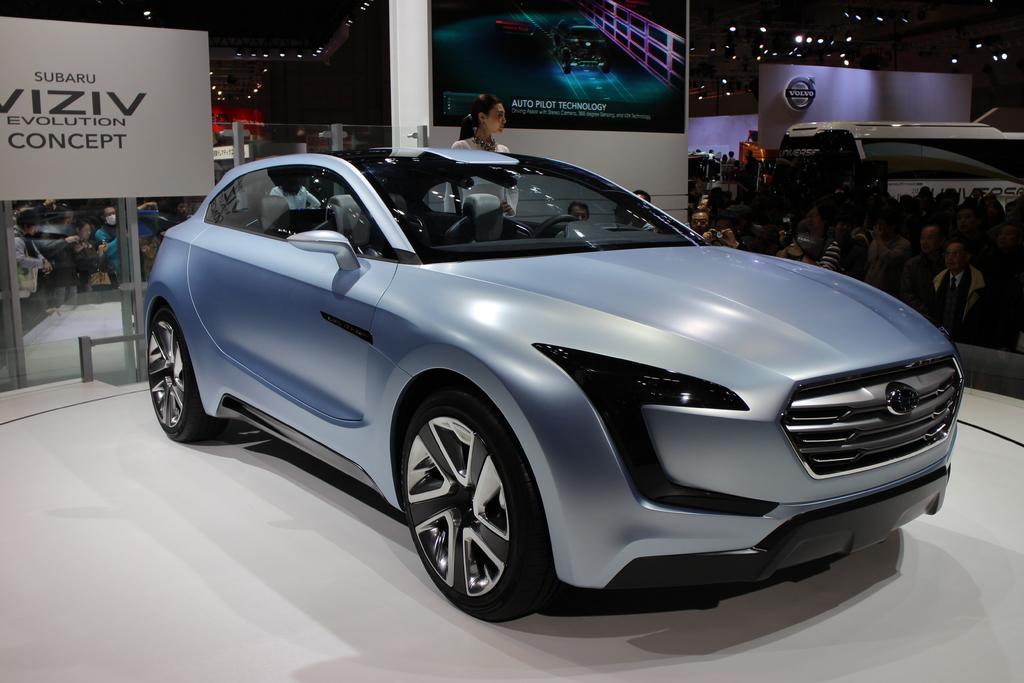In one or two sentences, can you explain what this image depicts? In the center of the image we can see car on the ground. In the background we can see persons, advertisements, logo, lights and wall. 